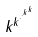Convert formula to latex. <formula><loc_0><loc_0><loc_500><loc_500>k ^ { k ^ { \cdot ^ { \cdot ^ { k ^ { k } } } } }</formula> 